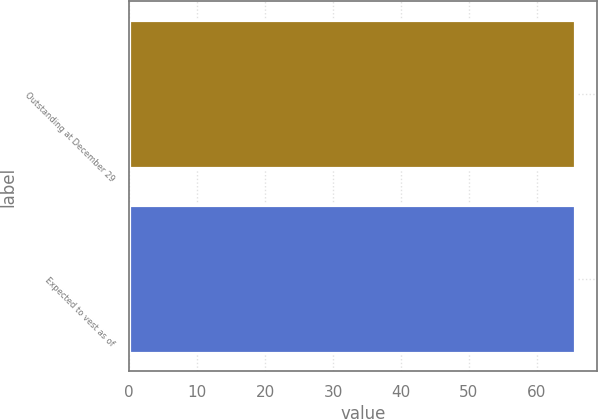Convert chart. <chart><loc_0><loc_0><loc_500><loc_500><bar_chart><fcel>Outstanding at December 29<fcel>Expected to vest as of<nl><fcel>65.6<fcel>65.58<nl></chart> 